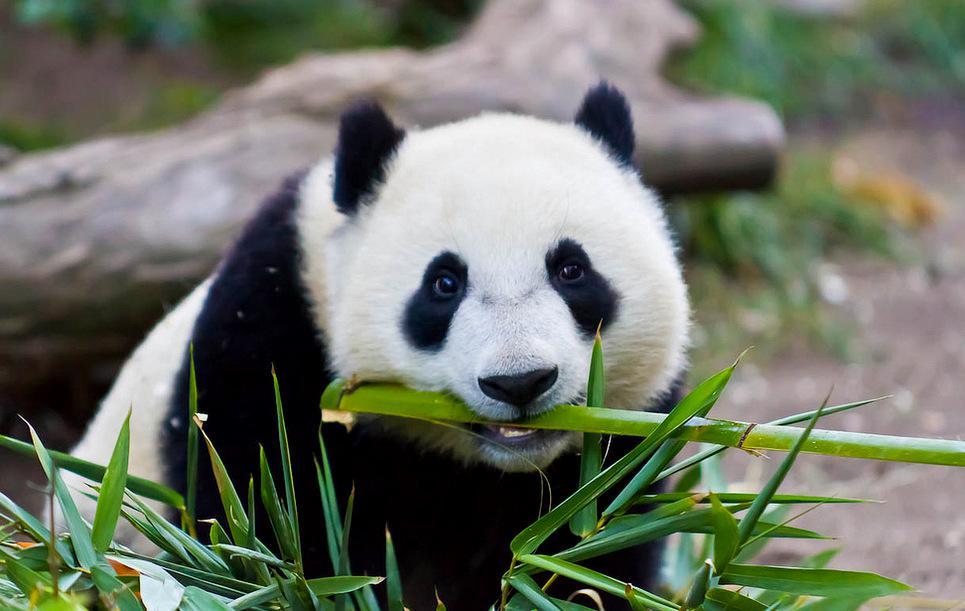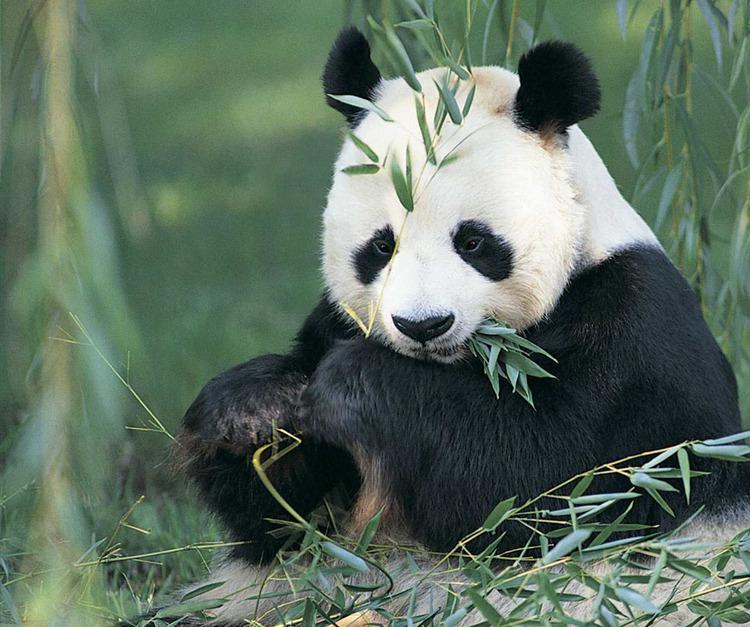The first image is the image on the left, the second image is the image on the right. Analyze the images presented: Is the assertion "There is at least one giant panda sitting in the grass and eating bamboo." valid? Answer yes or no. Yes. The first image is the image on the left, the second image is the image on the right. For the images shown, is this caption "At least one panda is eating." true? Answer yes or no. Yes. 